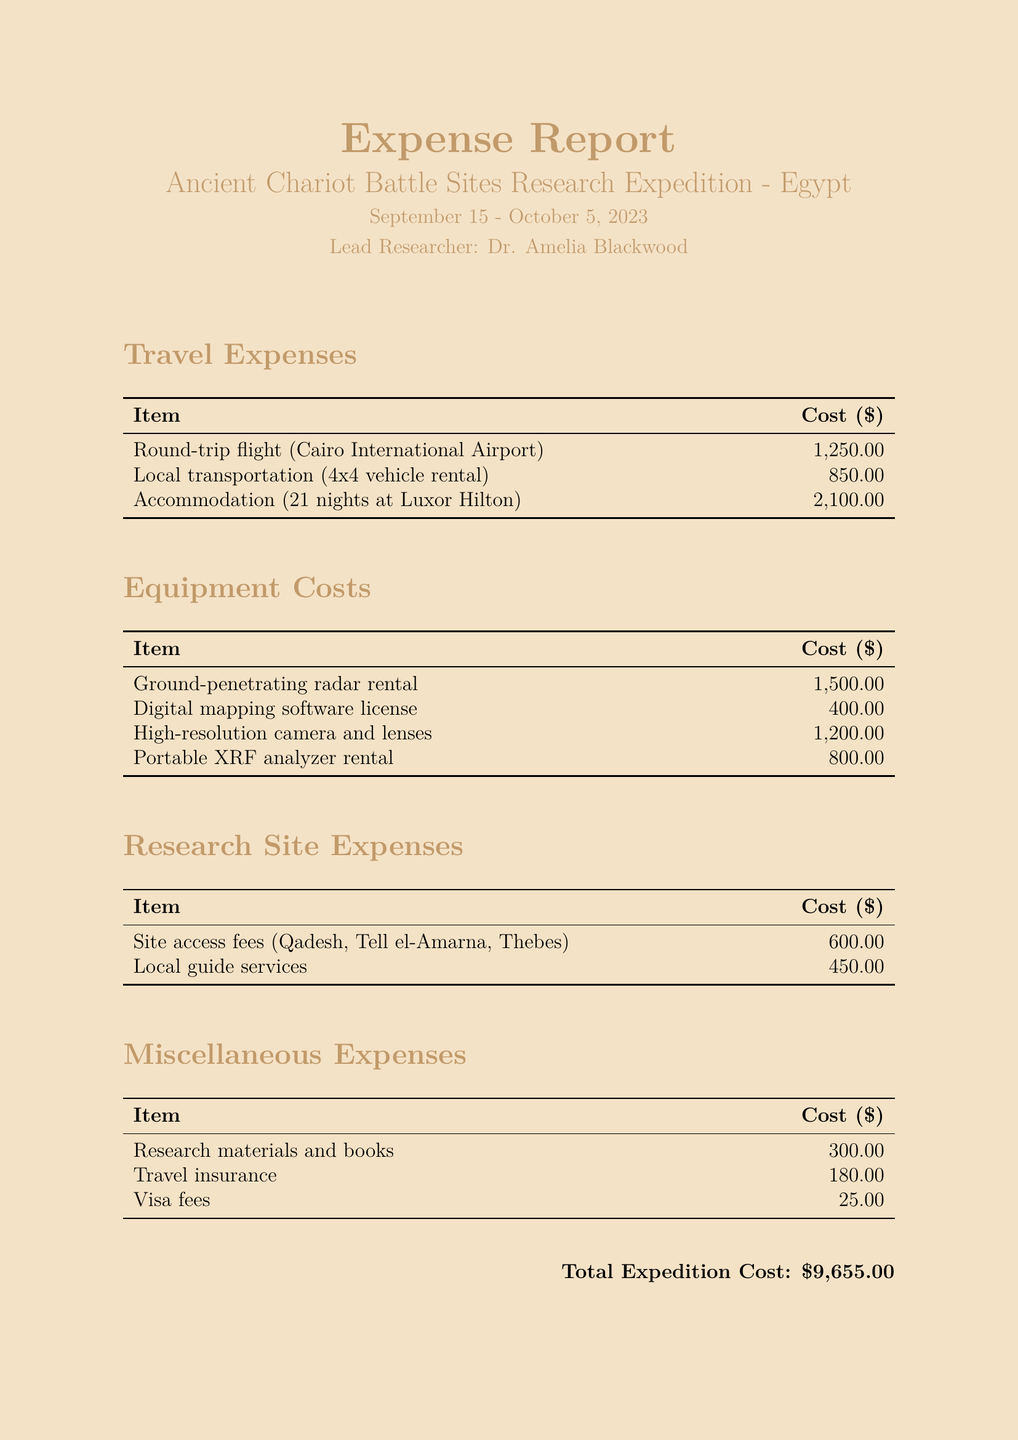What is the total expedition cost? The total expedition cost is presented at the end of the document, aggregating all expenses listed.
Answer: $9,655.00 Who is the lead researcher? The document states the lead researcher’s name right after the expedition title.
Answer: Dr. Amelia Blackwood How many nights was accommodation booked for? The accommodation section indicates the number of nights of stay.
Answer: 21 nights What was the cost of the ground-penetrating radar rental? The cost is specified in the equipment costs section of the document.
Answer: $1,500.00 What sites required access fees? The document lists specific sites that required fees under research site expenses.
Answer: Qadesh, Tell el-Amarna, Thebes What is the cost of travel insurance? The miscellaneous expenses section details the individual costs, including travel insurance.
Answer: $180.00 How much was spent on local guide services? The document indicates the cost for local guide services in the research site expenses section.
Answer: $450.00 What equipment was rented aside from the radar? The equipment costs section lists various rented items, and a secondary major item can be inferred.
Answer: Portable XRF analyzer What type of mapping software was licensed? The document identifies the specific software associated with a cost in the equipment section.
Answer: Digital mapping software license 